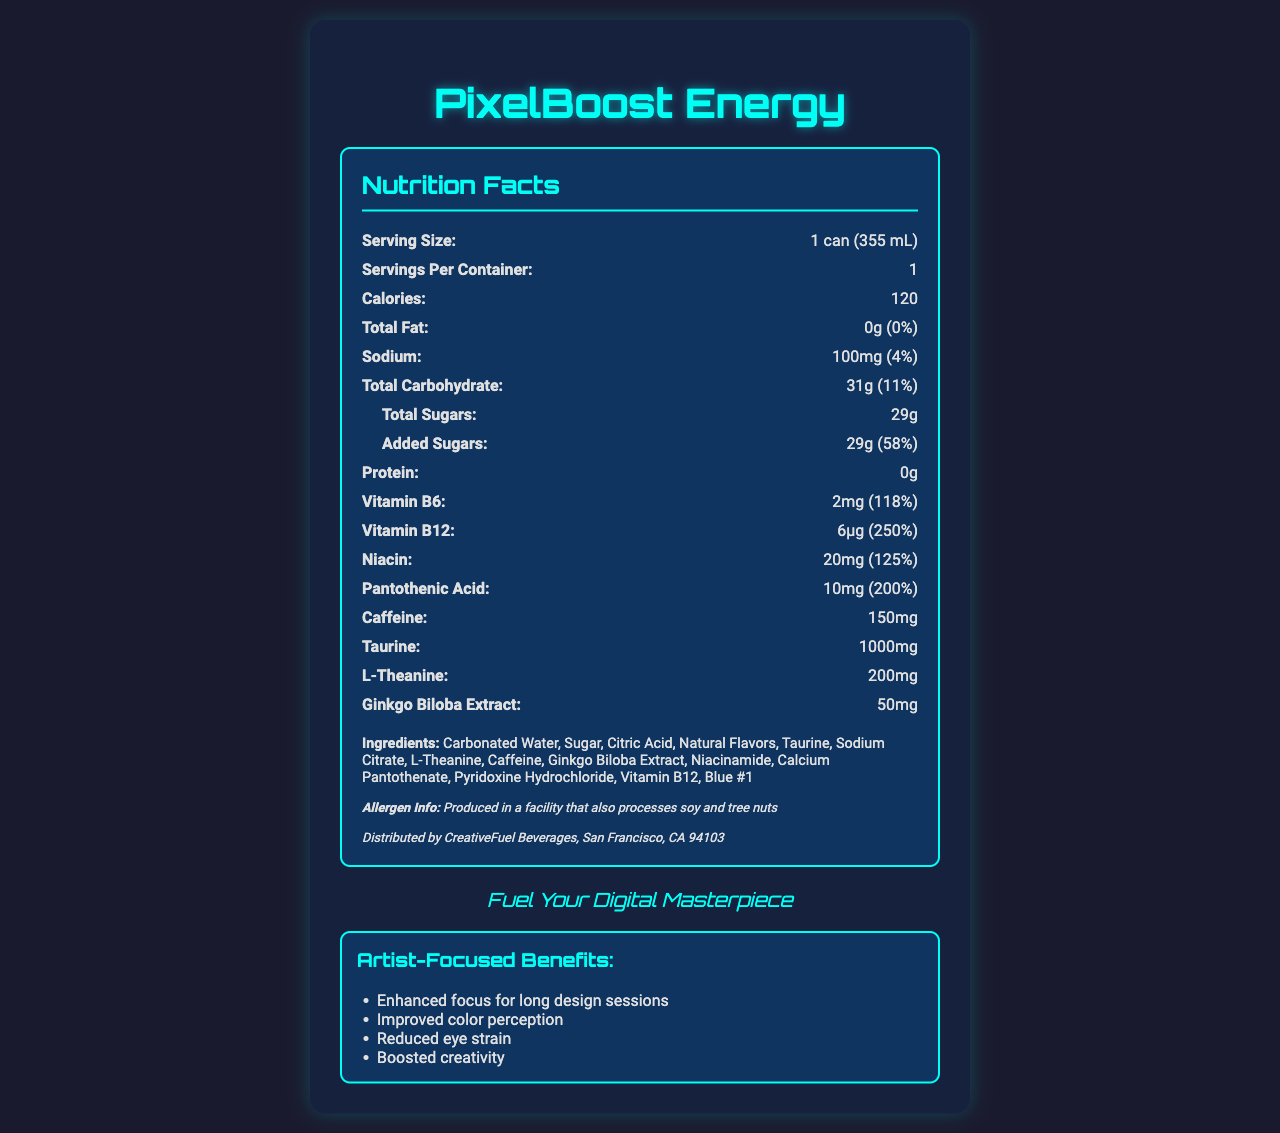what is the serving size for PixelBoost Energy? The document lists "1 can (355 mL)" as the serving size in the Nutrition Facts section.
Answer: 1 can (355 mL) How many calories are there per serving? The Nutrition Facts section states that there are 120 calories per serving.
Answer: 120 What is the total amount of sugars per serving? The Nutrition Facts lists "Total Sugars: 29g" under the carbohydrates section.
Answer: 29g How much caffeine does PixelBoost Energy contain? The amount of caffeine, 150mg, is specified in the Nutrition Facts section.
Answer: 150mg What company distributes PixelBoost Energy? The distribution information at the bottom of the Nutrition Facts section states it is distributed by CreativeFuel Beverages.
Answer: CreativeFuel Beverages Does PixelBoost Energy contain any fat? The document states that the total fat is 0g, which is 0% of the daily value.
Answer: No What are the artist-focused benefits of drinking PixelBoost Energy? The document lists these benefits in the "Artist-Focused Benefits" section near the bottom.
Answer: Enhanced focus for long design sessions, Improved color perception, Reduced eye strain, Boosted creativity Which vitamin is present at the highest daily value percentage? A. Vitamin B6 B. Vitamin B12 C. Niacin Vitamin B12 is listed at 250%, which is higher than Vitamin B6 (118%) and Niacin (125%).
Answer: B What is the sodium content per serving? A. 50mg B. 100mg C. 150mg D. 200mg The document shows the sodium content as "100mg (4%)", indicating the correct answer is 100mg.
Answer: B Does PixelBoost Energy contain any protein? Protein content is listed as "0g" in the Nutrition Facts section.
Answer: No What color is used in the styling of the PixelBoost Energy label? Various sections mention blue elements like "border-color: #00fff5" and "text-shadow: 0 0 10px rgba(0, 255, 255, 0.5)", indicating the use of blue color.
Answer: Blue Does PixelBoost Energy contain more carbohydrates or caffeine? The document indicates 31g of carbohydrates versus 150mg of caffeine. Since 150mg is less than 31g, it contains more carbohydrates.
Answer: Carbohydrates What is the main purpose of the PixelBoost Energy drink for artists? The "Artist-Focused Benefits" section details these benefits, which summarize the main purpose of the drink.
Answer: To enhance focus, improve color perception, reduce eye strain, and boost creativity. Does this product contain any allergens? The document states that PixelBoost Energy is produced in a facility that processes soy and tree nuts, but does not confirm if the product itself contains these allergens.
Answer: Not enough information 